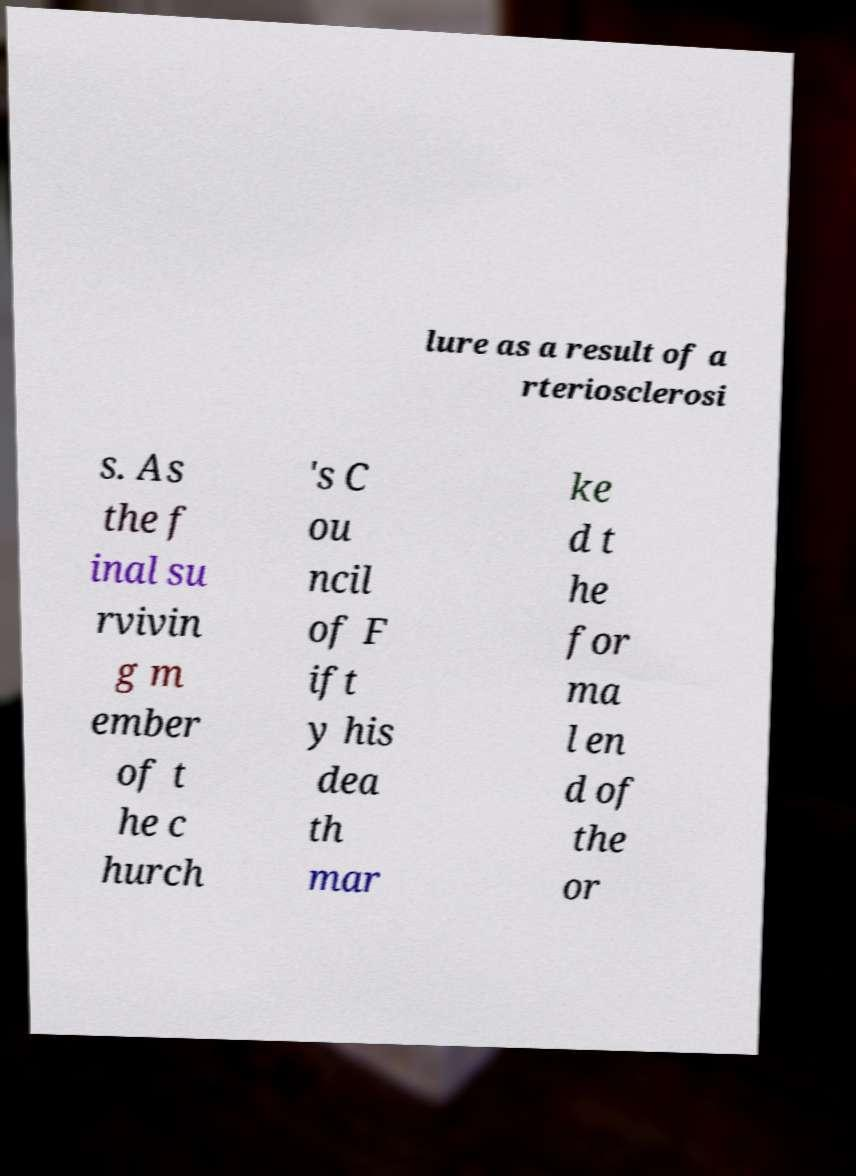Please identify and transcribe the text found in this image. lure as a result of a rteriosclerosi s. As the f inal su rvivin g m ember of t he c hurch 's C ou ncil of F ift y his dea th mar ke d t he for ma l en d of the or 